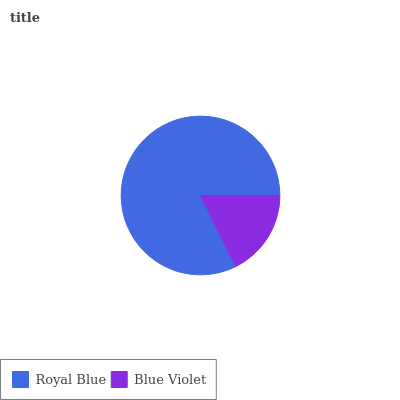Is Blue Violet the minimum?
Answer yes or no. Yes. Is Royal Blue the maximum?
Answer yes or no. Yes. Is Blue Violet the maximum?
Answer yes or no. No. Is Royal Blue greater than Blue Violet?
Answer yes or no. Yes. Is Blue Violet less than Royal Blue?
Answer yes or no. Yes. Is Blue Violet greater than Royal Blue?
Answer yes or no. No. Is Royal Blue less than Blue Violet?
Answer yes or no. No. Is Royal Blue the high median?
Answer yes or no. Yes. Is Blue Violet the low median?
Answer yes or no. Yes. Is Blue Violet the high median?
Answer yes or no. No. Is Royal Blue the low median?
Answer yes or no. No. 